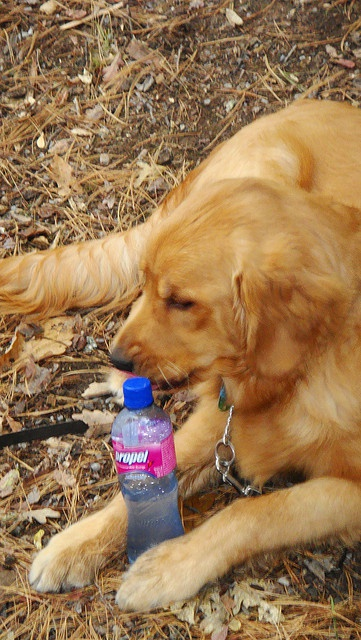Describe the objects in this image and their specific colors. I can see dog in olive, tan, and brown tones and bottle in olive, gray, and darkgray tones in this image. 